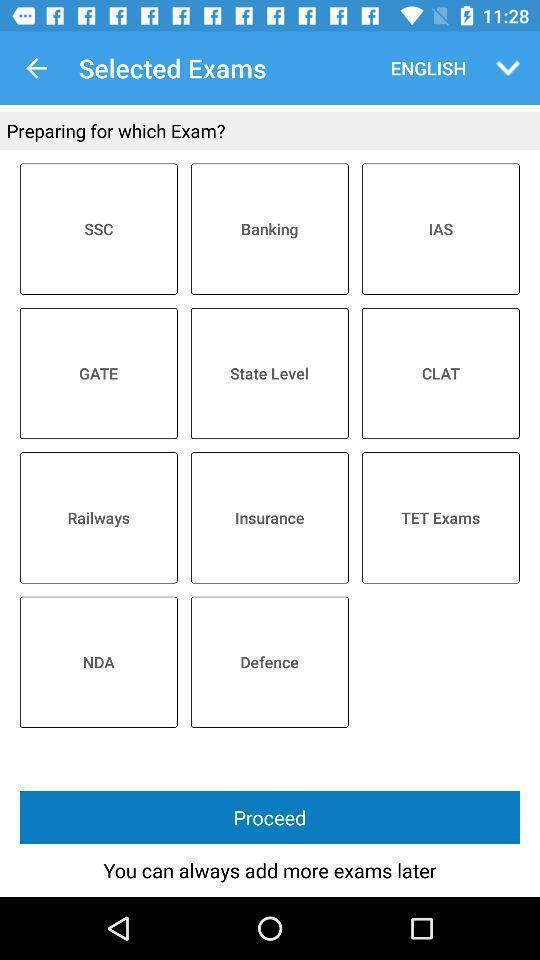Summarize the information in this screenshot. Social app showing list of exams. 